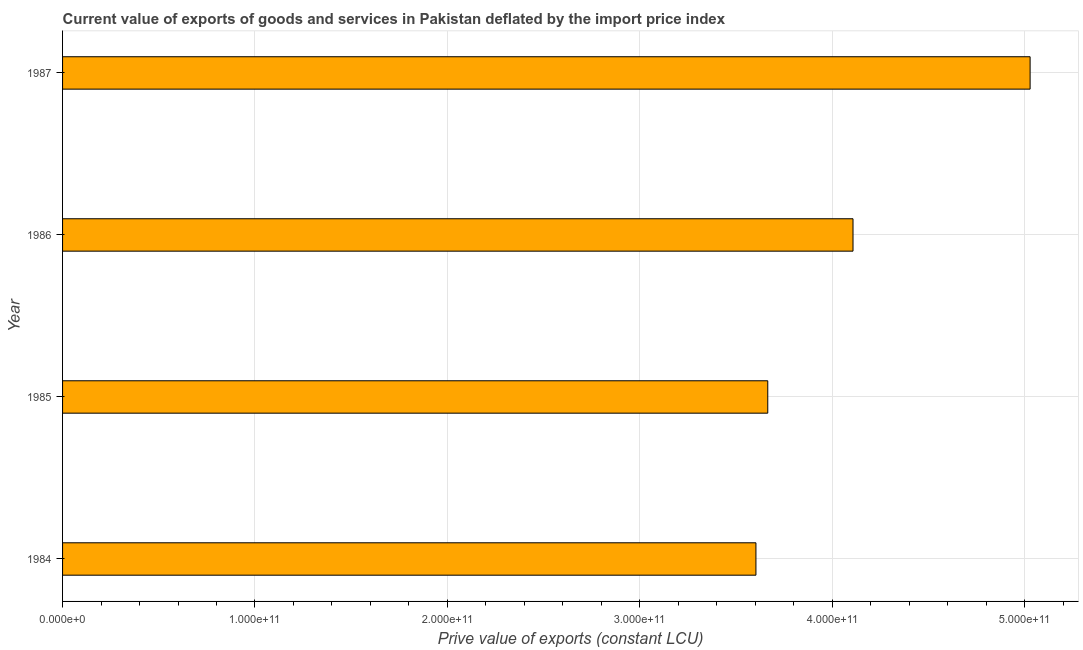Does the graph contain grids?
Provide a short and direct response. Yes. What is the title of the graph?
Your answer should be compact. Current value of exports of goods and services in Pakistan deflated by the import price index. What is the label or title of the X-axis?
Offer a very short reply. Prive value of exports (constant LCU). What is the price value of exports in 1984?
Offer a very short reply. 3.60e+11. Across all years, what is the maximum price value of exports?
Give a very brief answer. 5.03e+11. Across all years, what is the minimum price value of exports?
Provide a succinct answer. 3.60e+11. In which year was the price value of exports minimum?
Offer a terse response. 1984. What is the sum of the price value of exports?
Ensure brevity in your answer.  1.64e+12. What is the difference between the price value of exports in 1984 and 1987?
Provide a succinct answer. -1.42e+11. What is the average price value of exports per year?
Keep it short and to the point. 4.10e+11. What is the median price value of exports?
Your answer should be compact. 3.89e+11. In how many years, is the price value of exports greater than 440000000000 LCU?
Your answer should be compact. 1. Do a majority of the years between 1986 and 1985 (inclusive) have price value of exports greater than 500000000000 LCU?
Your answer should be compact. No. What is the ratio of the price value of exports in 1984 to that in 1986?
Your answer should be compact. 0.88. Is the price value of exports in 1984 less than that in 1987?
Your answer should be compact. Yes. Is the difference between the price value of exports in 1984 and 1987 greater than the difference between any two years?
Keep it short and to the point. Yes. What is the difference between the highest and the second highest price value of exports?
Ensure brevity in your answer.  9.20e+1. What is the difference between the highest and the lowest price value of exports?
Your answer should be compact. 1.42e+11. Are all the bars in the graph horizontal?
Your answer should be very brief. Yes. What is the difference between two consecutive major ticks on the X-axis?
Provide a short and direct response. 1.00e+11. What is the Prive value of exports (constant LCU) in 1984?
Make the answer very short. 3.60e+11. What is the Prive value of exports (constant LCU) of 1985?
Make the answer very short. 3.66e+11. What is the Prive value of exports (constant LCU) in 1986?
Make the answer very short. 4.11e+11. What is the Prive value of exports (constant LCU) in 1987?
Make the answer very short. 5.03e+11. What is the difference between the Prive value of exports (constant LCU) in 1984 and 1985?
Offer a terse response. -6.15e+09. What is the difference between the Prive value of exports (constant LCU) in 1984 and 1986?
Offer a very short reply. -5.04e+1. What is the difference between the Prive value of exports (constant LCU) in 1984 and 1987?
Your answer should be very brief. -1.42e+11. What is the difference between the Prive value of exports (constant LCU) in 1985 and 1986?
Provide a succinct answer. -4.43e+1. What is the difference between the Prive value of exports (constant LCU) in 1985 and 1987?
Provide a short and direct response. -1.36e+11. What is the difference between the Prive value of exports (constant LCU) in 1986 and 1987?
Provide a short and direct response. -9.20e+1. What is the ratio of the Prive value of exports (constant LCU) in 1984 to that in 1986?
Make the answer very short. 0.88. What is the ratio of the Prive value of exports (constant LCU) in 1984 to that in 1987?
Your answer should be compact. 0.72. What is the ratio of the Prive value of exports (constant LCU) in 1985 to that in 1986?
Provide a succinct answer. 0.89. What is the ratio of the Prive value of exports (constant LCU) in 1985 to that in 1987?
Give a very brief answer. 0.73. What is the ratio of the Prive value of exports (constant LCU) in 1986 to that in 1987?
Offer a terse response. 0.82. 